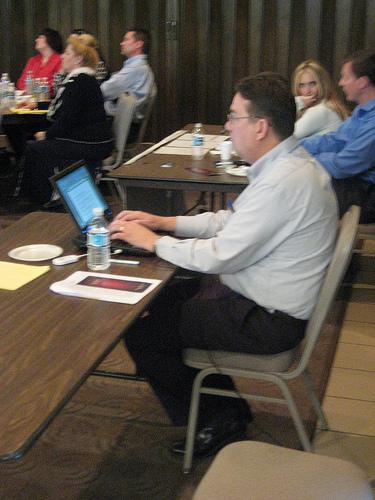Question: how are they?
Choices:
A. Crouched down.
B. Crowded together.
C. Laying down.
D. Seated.
Answer with the letter. Answer: D Question: what is he sitting on?
Choices:
A. Couch.
B. Bicycle.
C. Floor.
D. Chair.
Answer with the letter. Answer: D Question: how is the room?
Choices:
A. Bright.
B. Small.
C. Filled.
D. Crowded.
Answer with the letter. Answer: C 